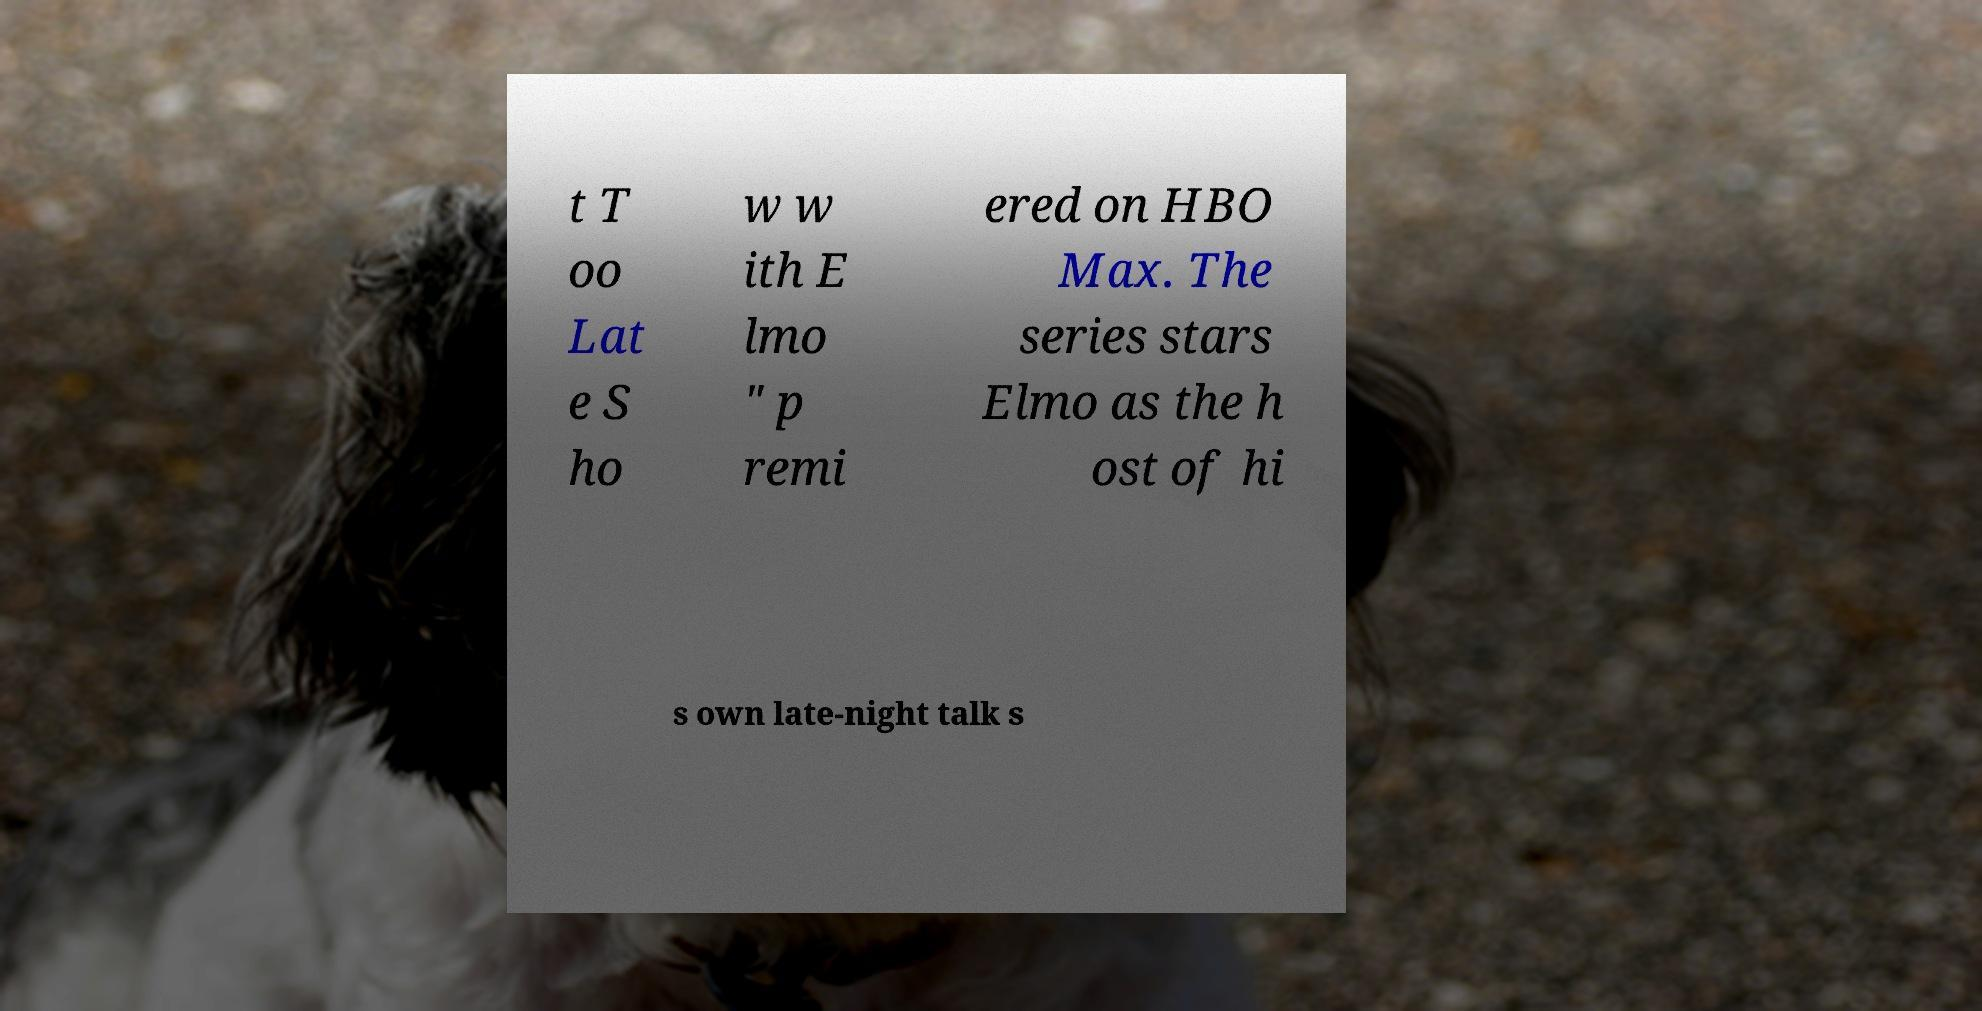For documentation purposes, I need the text within this image transcribed. Could you provide that? t T oo Lat e S ho w w ith E lmo " p remi ered on HBO Max. The series stars Elmo as the h ost of hi s own late-night talk s 